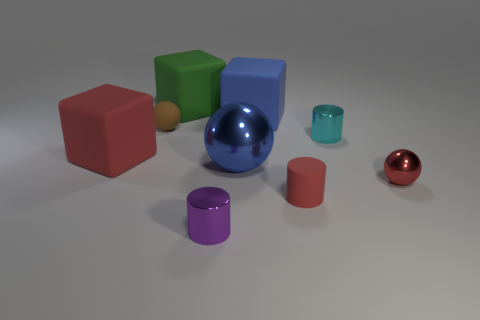Subtract all tiny metallic cylinders. How many cylinders are left? 1 Add 1 small metallic objects. How many objects exist? 10 Add 3 red cubes. How many red cubes exist? 4 Subtract 0 cyan blocks. How many objects are left? 9 Subtract all cylinders. How many objects are left? 6 Subtract all yellow cubes. Subtract all red cylinders. How many cubes are left? 3 Subtract all tiny brown objects. Subtract all blue matte objects. How many objects are left? 7 Add 4 brown spheres. How many brown spheres are left? 5 